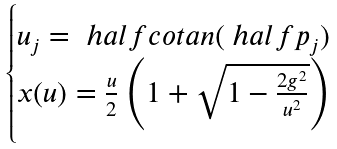Convert formula to latex. <formula><loc_0><loc_0><loc_500><loc_500>\begin{cases} u _ { j } = \ h a l f c o t a n ( \ h a l f p _ { j } ) \\ x ( u ) = \frac { u } { 2 } \left ( 1 + \sqrt { 1 - \frac { 2 g ^ { 2 } } { u ^ { 2 } } } \right ) \end{cases}</formula> 